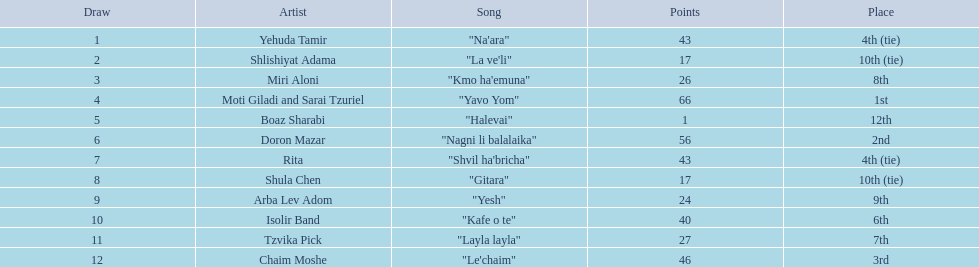What are the values? 43, 17, 26, 66, 1, 56, 43, 17, 24, 40, 27, 46. What is the minimum? 1. Which artist holds that quantity? Boaz Sharabi. 